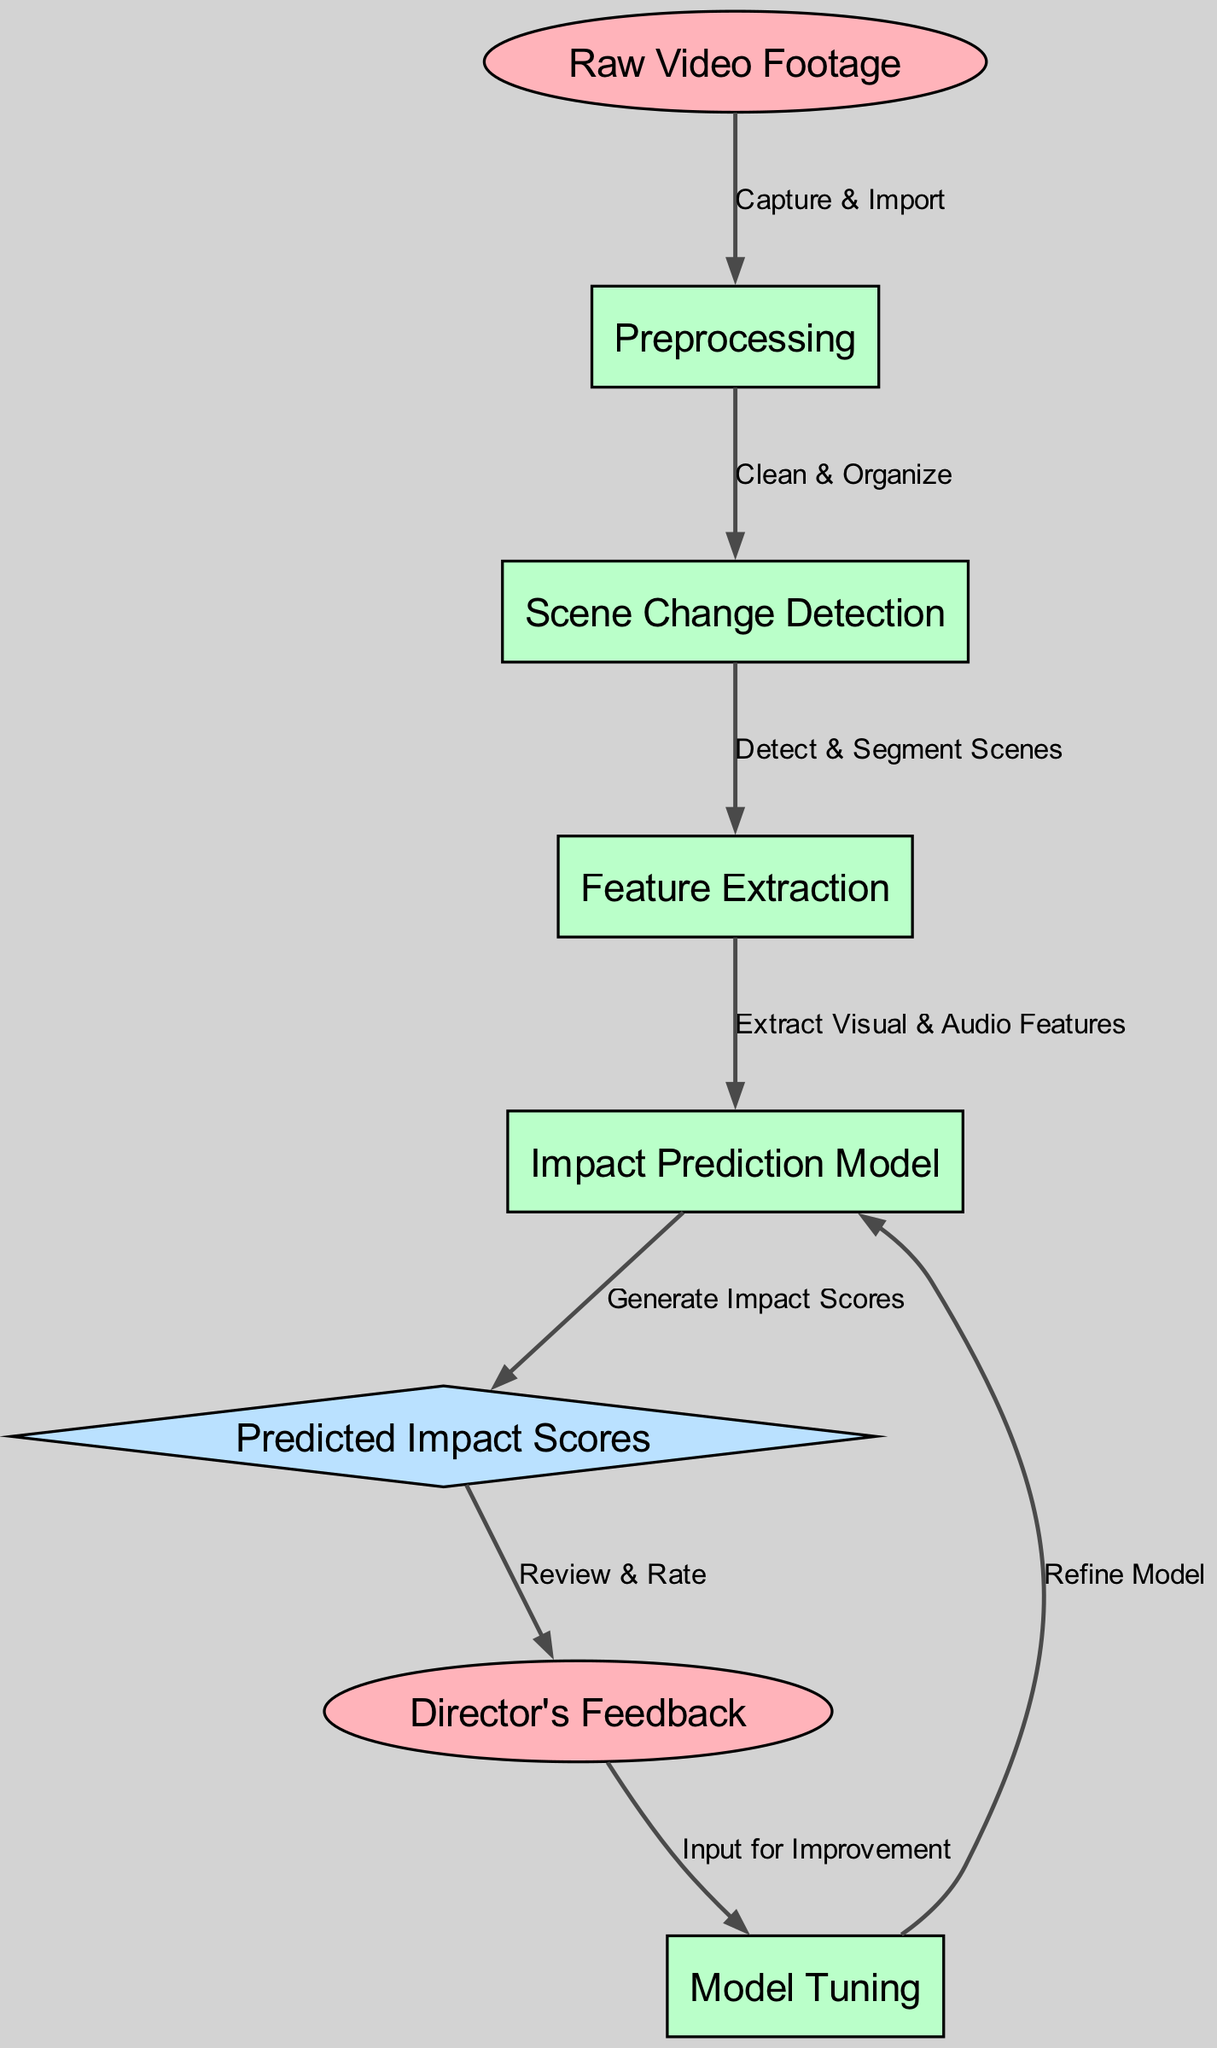What is the first node in the diagram? The first node in the diagram is labeled "Raw Video Footage," which is the starting point for the process.
Answer: Raw Video Footage How many process nodes are there in total? There are four nodes labeled as processes: "Preprocessing," "Scene Change Detection," "Feature Extraction," and "Impact Prediction Model." Thus, there are four process nodes in total.
Answer: 4 Which node directly follows "Preprocessing"? The node that directly follows "Preprocessing" is "Scene Change Detection," as indicated by the directed edge from the former to the latter.
Answer: Scene Change Detection What is the output of the impact model node? The output of the "Impact Prediction Model" node is "Predicted Impact Scores," as shown in the edge leading from this process node to the output node.
Answer: Predicted Impact Scores What feedback does the "Predicted Impact Scores" generate? The "Predicted Impact Scores" generate "Director's Feedback," which is solicited for review and rating from the director after scoring.
Answer: Director's Feedback Which two nodes are involved in the feedback loop? The nodes involved in the feedback loop are "Director's Feedback" and "Model Tuning," as feedback is input for improving the model.
Answer: Director's Feedback, Model Tuning What is the relationship between "Feature Extraction" and "Impact Prediction Model"? "Feature Extraction" provides input to the "Impact Prediction Model" by extracting visual and audio features, as represented by the directed edge between these two nodes.
Answer: Extract Visual & Audio Features How does the model improve based on the feedback? The model improves through "Model Tuning," which takes "Director's Feedback" as input to refine its predictions and accuracy in subsequent analysis.
Answer: Model Tuning 